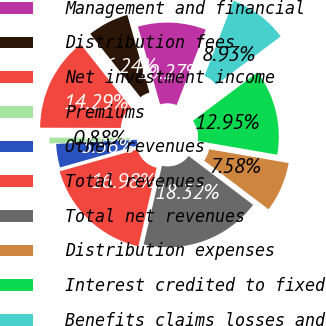Convert chart. <chart><loc_0><loc_0><loc_500><loc_500><pie_chart><fcel>Management and financial<fcel>Distribution fees<fcel>Net investment income<fcel>Premiums<fcel>Other revenues<fcel>Total revenues<fcel>Total net revenues<fcel>Distribution expenses<fcel>Interest credited to fixed<fcel>Benefits claims losses and<nl><fcel>10.27%<fcel>6.24%<fcel>14.29%<fcel>0.88%<fcel>3.56%<fcel>16.98%<fcel>18.32%<fcel>7.58%<fcel>12.95%<fcel>8.93%<nl></chart> 